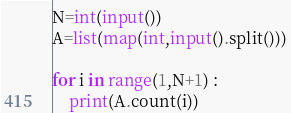Convert code to text. <code><loc_0><loc_0><loc_500><loc_500><_Python_>N=int(input())
A=list(map(int,input().split()))

for i in range(1,N+1) :
    print(A.count(i))</code> 